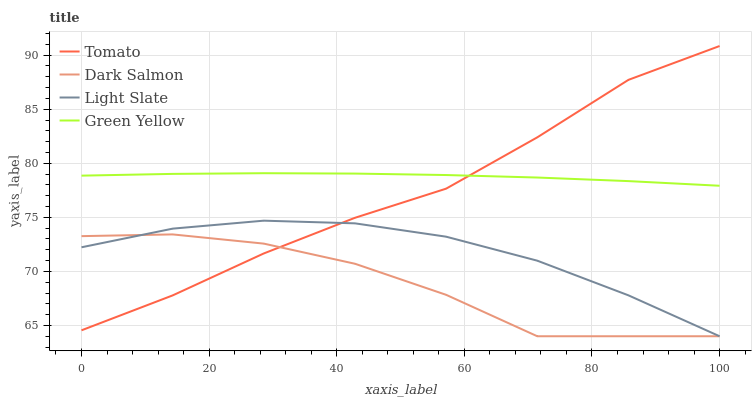Does Dark Salmon have the minimum area under the curve?
Answer yes or no. Yes. Does Green Yellow have the maximum area under the curve?
Answer yes or no. Yes. Does Light Slate have the minimum area under the curve?
Answer yes or no. No. Does Light Slate have the maximum area under the curve?
Answer yes or no. No. Is Green Yellow the smoothest?
Answer yes or no. Yes. Is Dark Salmon the roughest?
Answer yes or no. Yes. Is Light Slate the smoothest?
Answer yes or no. No. Is Light Slate the roughest?
Answer yes or no. No. Does Green Yellow have the lowest value?
Answer yes or no. No. Does Light Slate have the highest value?
Answer yes or no. No. Is Dark Salmon less than Green Yellow?
Answer yes or no. Yes. Is Green Yellow greater than Dark Salmon?
Answer yes or no. Yes. Does Dark Salmon intersect Green Yellow?
Answer yes or no. No. 